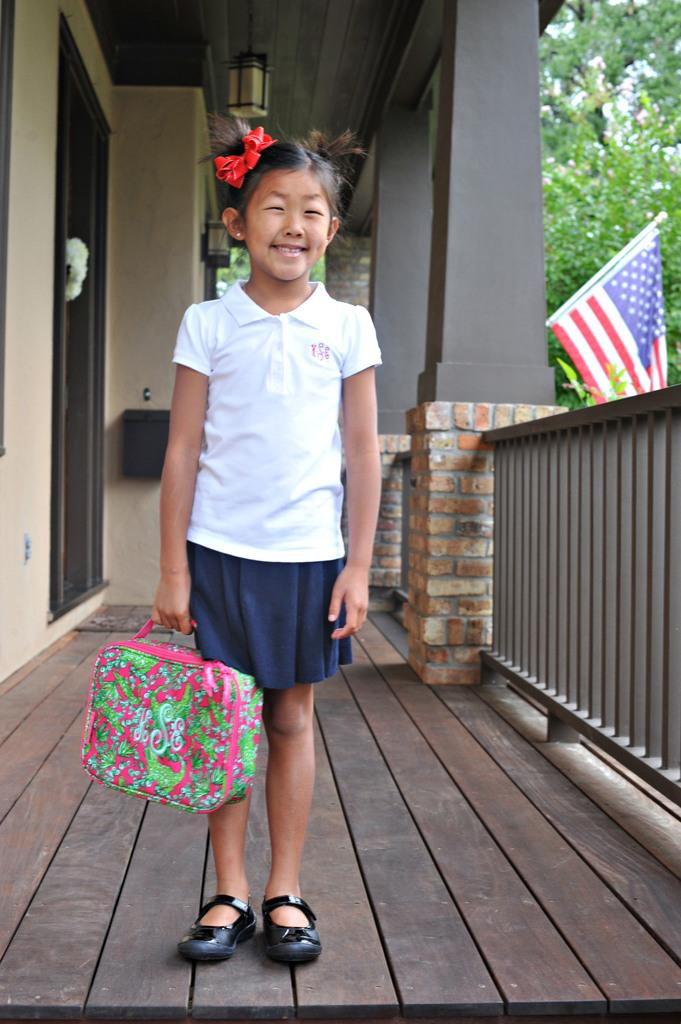What is the main subject of the image? There is a child in the image. What is the child holding? The child is holding a bag. What architectural features can be seen in the image? There are pillars and a door visible in the image. What is the source of light in the image? There is a ceiling light in the image. What can be seen in the background of the image? There are trees and a flag visible in the image. What type of barrier is present in the image? There is a fence in the image. What is the child's annual income in the image? There is no information about the child's income in the image. What type of game is being played in the image? There is no game being played in the image. 